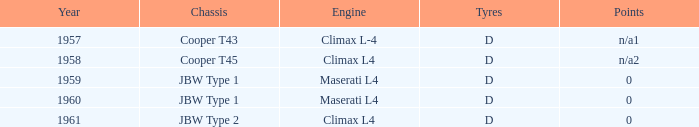What engine was for the vehicle with a cooper t43 chassis? Climax L-4. 